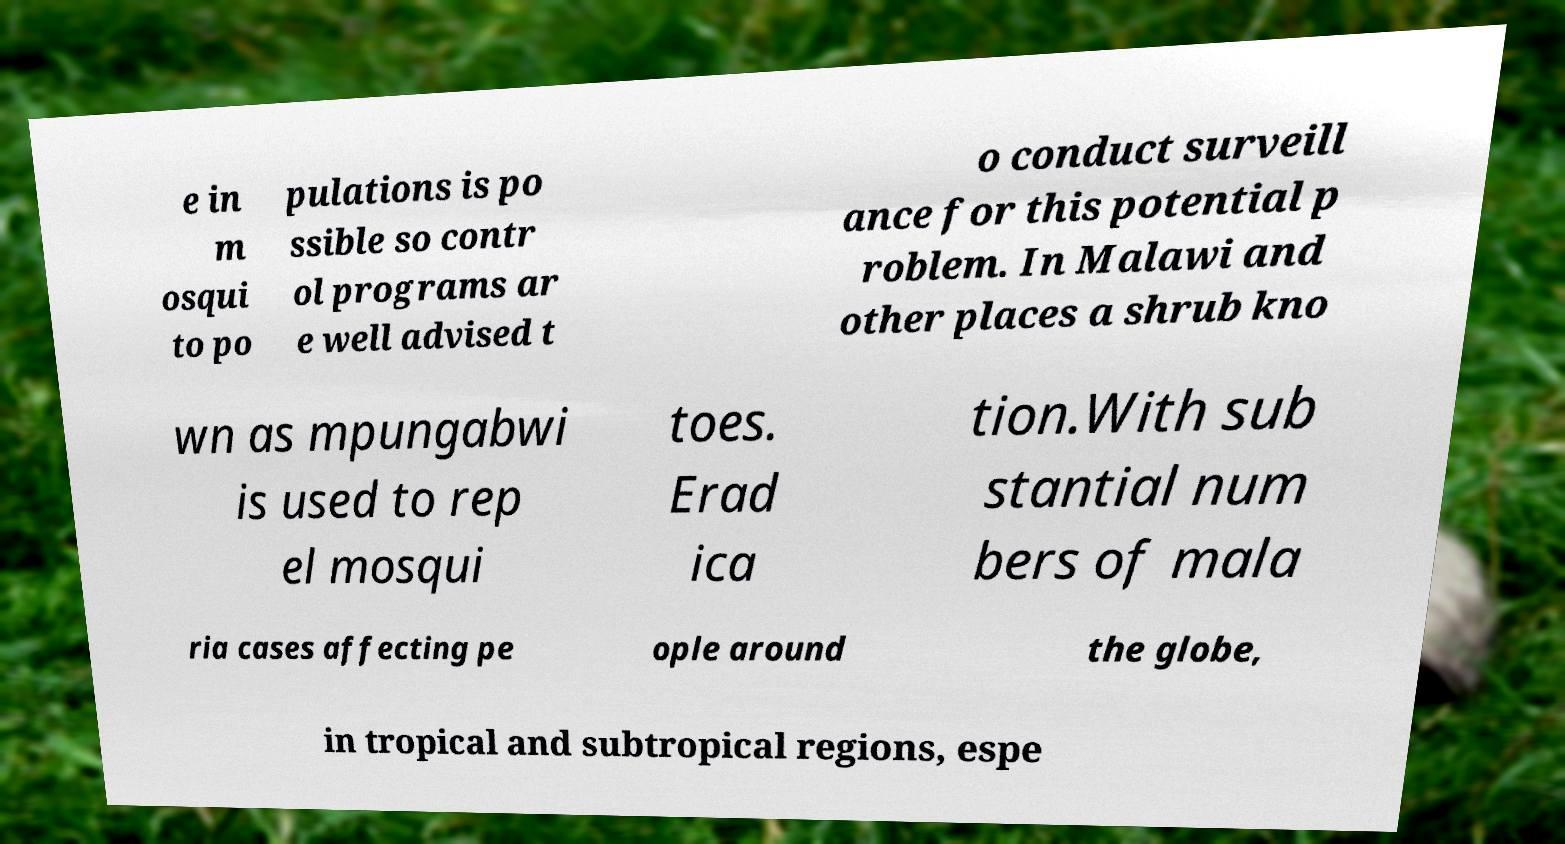Please read and relay the text visible in this image. What does it say? e in m osqui to po pulations is po ssible so contr ol programs ar e well advised t o conduct surveill ance for this potential p roblem. In Malawi and other places a shrub kno wn as mpungabwi is used to rep el mosqui toes. Erad ica tion.With sub stantial num bers of mala ria cases affecting pe ople around the globe, in tropical and subtropical regions, espe 